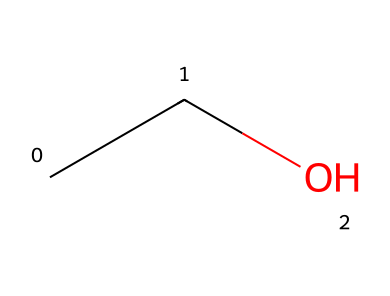How many carbon atoms are in this molecule? The SMILES representation "CCO" indicates there are two "C" atoms present in the structure.
Answer: 2 What type of chemical bond exists between the carbon and oxygen in this molecule? In the SMILES "CCO", the carbon (C) is bonded to an oxygen (O) with a single bond as implied by the sequence and the absence of any other bond notations.
Answer: single bond What is the molecular formula of ethanol? The molecular formula can be derived from the SMILES; there are 2 carbon (C) atoms, 6 hydrogen (H) atoms (each carbon typically connects with enough hydrogen to have four bonds), and 1 oxygen (O) atom. This gives us C2H6O.
Answer: C2H6O Why is ethanol considered a non-electrolyte? Ethanol does not dissociate into ions in solution, which characterizes it as a non-electrolyte. It stays intact as neutral molecules when dissolved in water.
Answer: does not dissociate What makes ethanol soluble in water despite being a non-electrolyte? Ethanol has a hydroxyl (-OH) group that forms hydrogen bonds with water molecules, facilitating its solubility despite being a non-electrolyte.
Answer: hydrogen bonds How many hydrogen atoms are connected to each carbon atom in ethanol? Each carbon atom in ethanol is connected to three hydrogen atoms because each carbon needs a total of four bonds and one bond is shared with the other carbon.
Answer: 3 